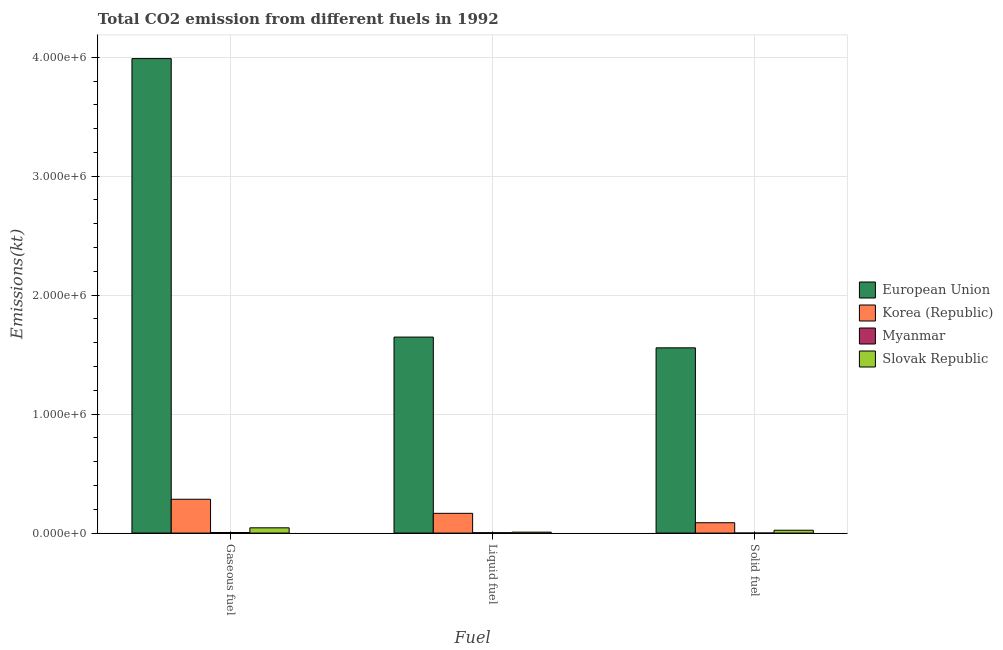How many groups of bars are there?
Give a very brief answer. 3. Are the number of bars on each tick of the X-axis equal?
Offer a terse response. Yes. What is the label of the 2nd group of bars from the left?
Keep it short and to the point. Liquid fuel. What is the amount of co2 emissions from solid fuel in European Union?
Offer a very short reply. 1.56e+06. Across all countries, what is the maximum amount of co2 emissions from liquid fuel?
Ensure brevity in your answer.  1.65e+06. Across all countries, what is the minimum amount of co2 emissions from liquid fuel?
Your answer should be compact. 2907.93. In which country was the amount of co2 emissions from liquid fuel maximum?
Your response must be concise. European Union. In which country was the amount of co2 emissions from solid fuel minimum?
Your response must be concise. Myanmar. What is the total amount of co2 emissions from gaseous fuel in the graph?
Ensure brevity in your answer.  4.32e+06. What is the difference between the amount of co2 emissions from liquid fuel in European Union and that in Myanmar?
Provide a short and direct response. 1.64e+06. What is the difference between the amount of co2 emissions from solid fuel in European Union and the amount of co2 emissions from liquid fuel in Korea (Republic)?
Your answer should be compact. 1.39e+06. What is the average amount of co2 emissions from liquid fuel per country?
Offer a very short reply. 4.56e+05. What is the difference between the amount of co2 emissions from liquid fuel and amount of co2 emissions from solid fuel in Myanmar?
Provide a succinct answer. 2786.92. What is the ratio of the amount of co2 emissions from liquid fuel in Slovak Republic to that in Korea (Republic)?
Offer a very short reply. 0.05. Is the amount of co2 emissions from solid fuel in Slovak Republic less than that in Myanmar?
Your response must be concise. No. What is the difference between the highest and the second highest amount of co2 emissions from solid fuel?
Provide a succinct answer. 1.47e+06. What is the difference between the highest and the lowest amount of co2 emissions from liquid fuel?
Offer a very short reply. 1.64e+06. In how many countries, is the amount of co2 emissions from solid fuel greater than the average amount of co2 emissions from solid fuel taken over all countries?
Keep it short and to the point. 1. What does the 2nd bar from the left in Gaseous fuel represents?
Ensure brevity in your answer.  Korea (Republic). What does the 1st bar from the right in Solid fuel represents?
Ensure brevity in your answer.  Slovak Republic. Is it the case that in every country, the sum of the amount of co2 emissions from gaseous fuel and amount of co2 emissions from liquid fuel is greater than the amount of co2 emissions from solid fuel?
Your answer should be compact. Yes. Are all the bars in the graph horizontal?
Keep it short and to the point. No. What is the difference between two consecutive major ticks on the Y-axis?
Make the answer very short. 1.00e+06. Where does the legend appear in the graph?
Your response must be concise. Center right. How many legend labels are there?
Ensure brevity in your answer.  4. What is the title of the graph?
Your answer should be very brief. Total CO2 emission from different fuels in 1992. Does "Mauritania" appear as one of the legend labels in the graph?
Provide a succinct answer. No. What is the label or title of the X-axis?
Make the answer very short. Fuel. What is the label or title of the Y-axis?
Provide a short and direct response. Emissions(kt). What is the Emissions(kt) in European Union in Gaseous fuel?
Ensure brevity in your answer.  3.99e+06. What is the Emissions(kt) in Korea (Republic) in Gaseous fuel?
Keep it short and to the point. 2.84e+05. What is the Emissions(kt) in Myanmar in Gaseous fuel?
Your response must be concise. 4888.11. What is the Emissions(kt) in Slovak Republic in Gaseous fuel?
Give a very brief answer. 4.42e+04. What is the Emissions(kt) in European Union in Liquid fuel?
Offer a terse response. 1.65e+06. What is the Emissions(kt) of Korea (Republic) in Liquid fuel?
Keep it short and to the point. 1.66e+05. What is the Emissions(kt) in Myanmar in Liquid fuel?
Your response must be concise. 2907.93. What is the Emissions(kt) in Slovak Republic in Liquid fuel?
Make the answer very short. 7726.37. What is the Emissions(kt) of European Union in Solid fuel?
Provide a short and direct response. 1.56e+06. What is the Emissions(kt) in Korea (Republic) in Solid fuel?
Your response must be concise. 8.70e+04. What is the Emissions(kt) in Myanmar in Solid fuel?
Offer a terse response. 121.01. What is the Emissions(kt) in Slovak Republic in Solid fuel?
Offer a terse response. 2.38e+04. Across all Fuel, what is the maximum Emissions(kt) in European Union?
Your answer should be compact. 3.99e+06. Across all Fuel, what is the maximum Emissions(kt) of Korea (Republic)?
Ensure brevity in your answer.  2.84e+05. Across all Fuel, what is the maximum Emissions(kt) of Myanmar?
Offer a terse response. 4888.11. Across all Fuel, what is the maximum Emissions(kt) in Slovak Republic?
Make the answer very short. 4.42e+04. Across all Fuel, what is the minimum Emissions(kt) in European Union?
Offer a very short reply. 1.56e+06. Across all Fuel, what is the minimum Emissions(kt) of Korea (Republic)?
Ensure brevity in your answer.  8.70e+04. Across all Fuel, what is the minimum Emissions(kt) in Myanmar?
Offer a very short reply. 121.01. Across all Fuel, what is the minimum Emissions(kt) of Slovak Republic?
Give a very brief answer. 7726.37. What is the total Emissions(kt) in European Union in the graph?
Keep it short and to the point. 7.19e+06. What is the total Emissions(kt) of Korea (Republic) in the graph?
Keep it short and to the point. 5.37e+05. What is the total Emissions(kt) of Myanmar in the graph?
Ensure brevity in your answer.  7917.05. What is the total Emissions(kt) in Slovak Republic in the graph?
Your response must be concise. 7.57e+04. What is the difference between the Emissions(kt) in European Union in Gaseous fuel and that in Liquid fuel?
Your answer should be very brief. 2.34e+06. What is the difference between the Emissions(kt) of Korea (Republic) in Gaseous fuel and that in Liquid fuel?
Your response must be concise. 1.18e+05. What is the difference between the Emissions(kt) of Myanmar in Gaseous fuel and that in Liquid fuel?
Your answer should be very brief. 1980.18. What is the difference between the Emissions(kt) of Slovak Republic in Gaseous fuel and that in Liquid fuel?
Make the answer very short. 3.65e+04. What is the difference between the Emissions(kt) in European Union in Gaseous fuel and that in Solid fuel?
Offer a terse response. 2.43e+06. What is the difference between the Emissions(kt) of Korea (Republic) in Gaseous fuel and that in Solid fuel?
Your answer should be very brief. 1.97e+05. What is the difference between the Emissions(kt) of Myanmar in Gaseous fuel and that in Solid fuel?
Your answer should be very brief. 4767.1. What is the difference between the Emissions(kt) in Slovak Republic in Gaseous fuel and that in Solid fuel?
Ensure brevity in your answer.  2.04e+04. What is the difference between the Emissions(kt) in European Union in Liquid fuel and that in Solid fuel?
Give a very brief answer. 9.03e+04. What is the difference between the Emissions(kt) in Korea (Republic) in Liquid fuel and that in Solid fuel?
Your answer should be compact. 7.89e+04. What is the difference between the Emissions(kt) of Myanmar in Liquid fuel and that in Solid fuel?
Your answer should be compact. 2786.92. What is the difference between the Emissions(kt) of Slovak Republic in Liquid fuel and that in Solid fuel?
Your response must be concise. -1.61e+04. What is the difference between the Emissions(kt) of European Union in Gaseous fuel and the Emissions(kt) of Korea (Republic) in Liquid fuel?
Offer a terse response. 3.82e+06. What is the difference between the Emissions(kt) in European Union in Gaseous fuel and the Emissions(kt) in Myanmar in Liquid fuel?
Ensure brevity in your answer.  3.99e+06. What is the difference between the Emissions(kt) in European Union in Gaseous fuel and the Emissions(kt) in Slovak Republic in Liquid fuel?
Your answer should be very brief. 3.98e+06. What is the difference between the Emissions(kt) in Korea (Republic) in Gaseous fuel and the Emissions(kt) in Myanmar in Liquid fuel?
Provide a succinct answer. 2.81e+05. What is the difference between the Emissions(kt) of Korea (Republic) in Gaseous fuel and the Emissions(kt) of Slovak Republic in Liquid fuel?
Offer a very short reply. 2.77e+05. What is the difference between the Emissions(kt) of Myanmar in Gaseous fuel and the Emissions(kt) of Slovak Republic in Liquid fuel?
Keep it short and to the point. -2838.26. What is the difference between the Emissions(kt) of European Union in Gaseous fuel and the Emissions(kt) of Korea (Republic) in Solid fuel?
Give a very brief answer. 3.90e+06. What is the difference between the Emissions(kt) of European Union in Gaseous fuel and the Emissions(kt) of Myanmar in Solid fuel?
Give a very brief answer. 3.99e+06. What is the difference between the Emissions(kt) in European Union in Gaseous fuel and the Emissions(kt) in Slovak Republic in Solid fuel?
Give a very brief answer. 3.96e+06. What is the difference between the Emissions(kt) in Korea (Republic) in Gaseous fuel and the Emissions(kt) in Myanmar in Solid fuel?
Offer a terse response. 2.84e+05. What is the difference between the Emissions(kt) of Korea (Republic) in Gaseous fuel and the Emissions(kt) of Slovak Republic in Solid fuel?
Ensure brevity in your answer.  2.60e+05. What is the difference between the Emissions(kt) of Myanmar in Gaseous fuel and the Emissions(kt) of Slovak Republic in Solid fuel?
Provide a short and direct response. -1.89e+04. What is the difference between the Emissions(kt) of European Union in Liquid fuel and the Emissions(kt) of Korea (Republic) in Solid fuel?
Keep it short and to the point. 1.56e+06. What is the difference between the Emissions(kt) in European Union in Liquid fuel and the Emissions(kt) in Myanmar in Solid fuel?
Your response must be concise. 1.65e+06. What is the difference between the Emissions(kt) in European Union in Liquid fuel and the Emissions(kt) in Slovak Republic in Solid fuel?
Provide a succinct answer. 1.62e+06. What is the difference between the Emissions(kt) of Korea (Republic) in Liquid fuel and the Emissions(kt) of Myanmar in Solid fuel?
Provide a short and direct response. 1.66e+05. What is the difference between the Emissions(kt) of Korea (Republic) in Liquid fuel and the Emissions(kt) of Slovak Republic in Solid fuel?
Make the answer very short. 1.42e+05. What is the difference between the Emissions(kt) in Myanmar in Liquid fuel and the Emissions(kt) in Slovak Republic in Solid fuel?
Give a very brief answer. -2.09e+04. What is the average Emissions(kt) of European Union per Fuel?
Make the answer very short. 2.40e+06. What is the average Emissions(kt) in Korea (Republic) per Fuel?
Your answer should be compact. 1.79e+05. What is the average Emissions(kt) in Myanmar per Fuel?
Your answer should be very brief. 2639.02. What is the average Emissions(kt) of Slovak Republic per Fuel?
Offer a very short reply. 2.52e+04. What is the difference between the Emissions(kt) of European Union and Emissions(kt) of Korea (Republic) in Gaseous fuel?
Offer a terse response. 3.70e+06. What is the difference between the Emissions(kt) of European Union and Emissions(kt) of Myanmar in Gaseous fuel?
Make the answer very short. 3.98e+06. What is the difference between the Emissions(kt) in European Union and Emissions(kt) in Slovak Republic in Gaseous fuel?
Your answer should be compact. 3.94e+06. What is the difference between the Emissions(kt) of Korea (Republic) and Emissions(kt) of Myanmar in Gaseous fuel?
Provide a short and direct response. 2.79e+05. What is the difference between the Emissions(kt) in Korea (Republic) and Emissions(kt) in Slovak Republic in Gaseous fuel?
Provide a succinct answer. 2.40e+05. What is the difference between the Emissions(kt) of Myanmar and Emissions(kt) of Slovak Republic in Gaseous fuel?
Provide a short and direct response. -3.93e+04. What is the difference between the Emissions(kt) of European Union and Emissions(kt) of Korea (Republic) in Liquid fuel?
Provide a short and direct response. 1.48e+06. What is the difference between the Emissions(kt) in European Union and Emissions(kt) in Myanmar in Liquid fuel?
Ensure brevity in your answer.  1.64e+06. What is the difference between the Emissions(kt) of European Union and Emissions(kt) of Slovak Republic in Liquid fuel?
Ensure brevity in your answer.  1.64e+06. What is the difference between the Emissions(kt) in Korea (Republic) and Emissions(kt) in Myanmar in Liquid fuel?
Offer a terse response. 1.63e+05. What is the difference between the Emissions(kt) in Korea (Republic) and Emissions(kt) in Slovak Republic in Liquid fuel?
Provide a short and direct response. 1.58e+05. What is the difference between the Emissions(kt) in Myanmar and Emissions(kt) in Slovak Republic in Liquid fuel?
Keep it short and to the point. -4818.44. What is the difference between the Emissions(kt) of European Union and Emissions(kt) of Korea (Republic) in Solid fuel?
Make the answer very short. 1.47e+06. What is the difference between the Emissions(kt) of European Union and Emissions(kt) of Myanmar in Solid fuel?
Keep it short and to the point. 1.56e+06. What is the difference between the Emissions(kt) of European Union and Emissions(kt) of Slovak Republic in Solid fuel?
Provide a succinct answer. 1.53e+06. What is the difference between the Emissions(kt) of Korea (Republic) and Emissions(kt) of Myanmar in Solid fuel?
Keep it short and to the point. 8.68e+04. What is the difference between the Emissions(kt) in Korea (Republic) and Emissions(kt) in Slovak Republic in Solid fuel?
Your answer should be compact. 6.31e+04. What is the difference between the Emissions(kt) of Myanmar and Emissions(kt) of Slovak Republic in Solid fuel?
Keep it short and to the point. -2.37e+04. What is the ratio of the Emissions(kt) in European Union in Gaseous fuel to that in Liquid fuel?
Provide a succinct answer. 2.42. What is the ratio of the Emissions(kt) of Korea (Republic) in Gaseous fuel to that in Liquid fuel?
Give a very brief answer. 1.71. What is the ratio of the Emissions(kt) in Myanmar in Gaseous fuel to that in Liquid fuel?
Your response must be concise. 1.68. What is the ratio of the Emissions(kt) of Slovak Republic in Gaseous fuel to that in Liquid fuel?
Your answer should be very brief. 5.72. What is the ratio of the Emissions(kt) of European Union in Gaseous fuel to that in Solid fuel?
Make the answer very short. 2.56. What is the ratio of the Emissions(kt) in Korea (Republic) in Gaseous fuel to that in Solid fuel?
Make the answer very short. 3.27. What is the ratio of the Emissions(kt) of Myanmar in Gaseous fuel to that in Solid fuel?
Your response must be concise. 40.39. What is the ratio of the Emissions(kt) of Slovak Republic in Gaseous fuel to that in Solid fuel?
Provide a succinct answer. 1.86. What is the ratio of the Emissions(kt) of European Union in Liquid fuel to that in Solid fuel?
Provide a succinct answer. 1.06. What is the ratio of the Emissions(kt) in Korea (Republic) in Liquid fuel to that in Solid fuel?
Provide a succinct answer. 1.91. What is the ratio of the Emissions(kt) of Myanmar in Liquid fuel to that in Solid fuel?
Make the answer very short. 24.03. What is the ratio of the Emissions(kt) in Slovak Republic in Liquid fuel to that in Solid fuel?
Ensure brevity in your answer.  0.32. What is the difference between the highest and the second highest Emissions(kt) in European Union?
Your answer should be very brief. 2.34e+06. What is the difference between the highest and the second highest Emissions(kt) in Korea (Republic)?
Make the answer very short. 1.18e+05. What is the difference between the highest and the second highest Emissions(kt) in Myanmar?
Offer a terse response. 1980.18. What is the difference between the highest and the second highest Emissions(kt) of Slovak Republic?
Your answer should be compact. 2.04e+04. What is the difference between the highest and the lowest Emissions(kt) of European Union?
Your response must be concise. 2.43e+06. What is the difference between the highest and the lowest Emissions(kt) in Korea (Republic)?
Provide a succinct answer. 1.97e+05. What is the difference between the highest and the lowest Emissions(kt) in Myanmar?
Provide a short and direct response. 4767.1. What is the difference between the highest and the lowest Emissions(kt) of Slovak Republic?
Offer a terse response. 3.65e+04. 